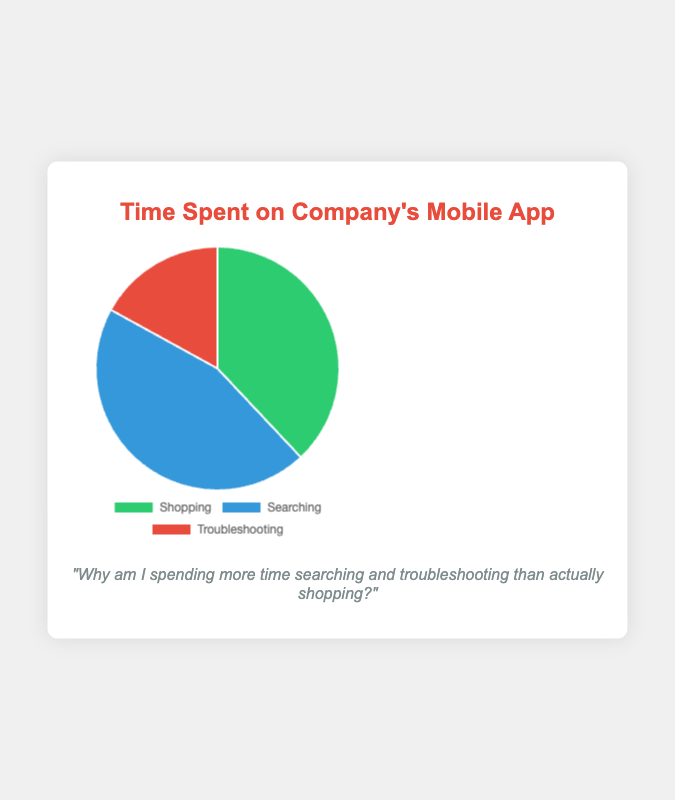How much more percentage of time is spent on Searching compared to Troubleshooting? To find this, subtract the percentage of time spent on Troubleshooting from the percentage of time spent on Searching: 45% - 17% = 28%.
Answer: 28% What is the total percentage of time spent on activities other than Shopping? To find this, sum the percentages of time spent on Searching and Troubleshooting: 45% + 17% = 62%.
Answer: 62% Which activity takes up the largest percentage of time? By comparing the given percentages, the activity with the highest percentage is Searching (45%).
Answer: Searching What is the percentage difference between Shopping and Troubleshooting? Subtract the percentage of time spent on Troubleshooting from the percentage of time spent on Shopping: 38% - 17% = 21%.
Answer: 21% What is the combined percentage of time spent on Shopping and Searching? To find this, sum the percentages of time spent on Shopping and Searching: 38% + 45% = 83%.
Answer: 83% Which activity is represented by the green color in the pie chart? The green color represents Shopping.
Answer: Shopping If you combine Shopping and Troubleshooting percentages, does it exceed the Searching percentage? Sum the percentages of Shopping and Troubleshooting: 38% + 17% = 55%. Since 55% is greater than 45%, it does exceed the Searching percentage.
Answer: Yes Which activity uses up nearly half of the total time? Searching takes up 45%, which is nearly half of the total time.
Answer: Searching What percentage of the total time does Troubleshooting take up? The percentage of time spent on Troubleshooting is provided as 17%.
Answer: 17% Is the time spent on Shopping less than the time spent on Searching? Yes, because 38% (Shopping) is less than 45% (Searching).
Answer: Yes 